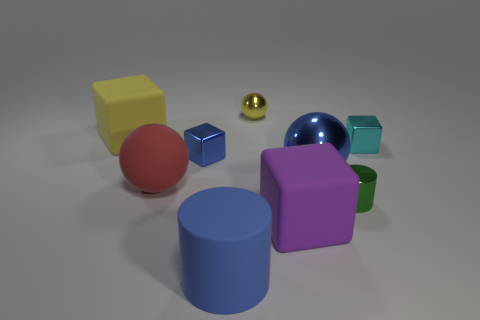Does the yellow ball have the same material as the green cylinder?
Your answer should be compact. Yes. What is the size of the thing that is both in front of the big red matte sphere and right of the purple block?
Your answer should be very brief. Small. There is a tiny yellow thing; what shape is it?
Give a very brief answer. Sphere. How many things are big red rubber things or rubber things that are in front of the blue sphere?
Ensure brevity in your answer.  3. There is a shiny block right of the purple matte cube; is it the same color as the matte sphere?
Provide a succinct answer. No. There is a large thing that is on the right side of the big red object and behind the tiny green metal object; what is its color?
Provide a succinct answer. Blue. What is the tiny cube that is right of the tiny green metal object made of?
Keep it short and to the point. Metal. What is the size of the yellow cube?
Offer a terse response. Large. What number of brown things are spheres or blocks?
Your answer should be compact. 0. There is a thing that is in front of the block that is in front of the tiny green thing; what is its size?
Keep it short and to the point. Large. 